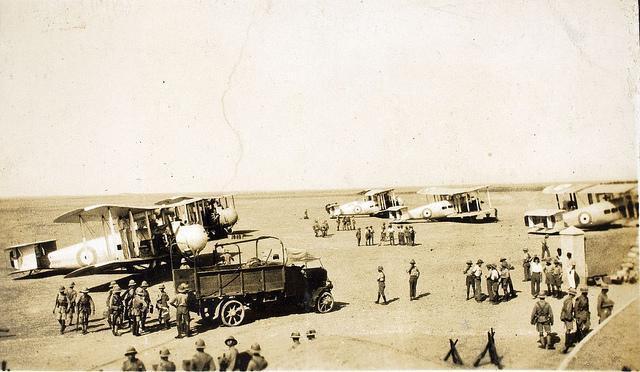How many airplanes are in the picture?
Give a very brief answer. 3. 